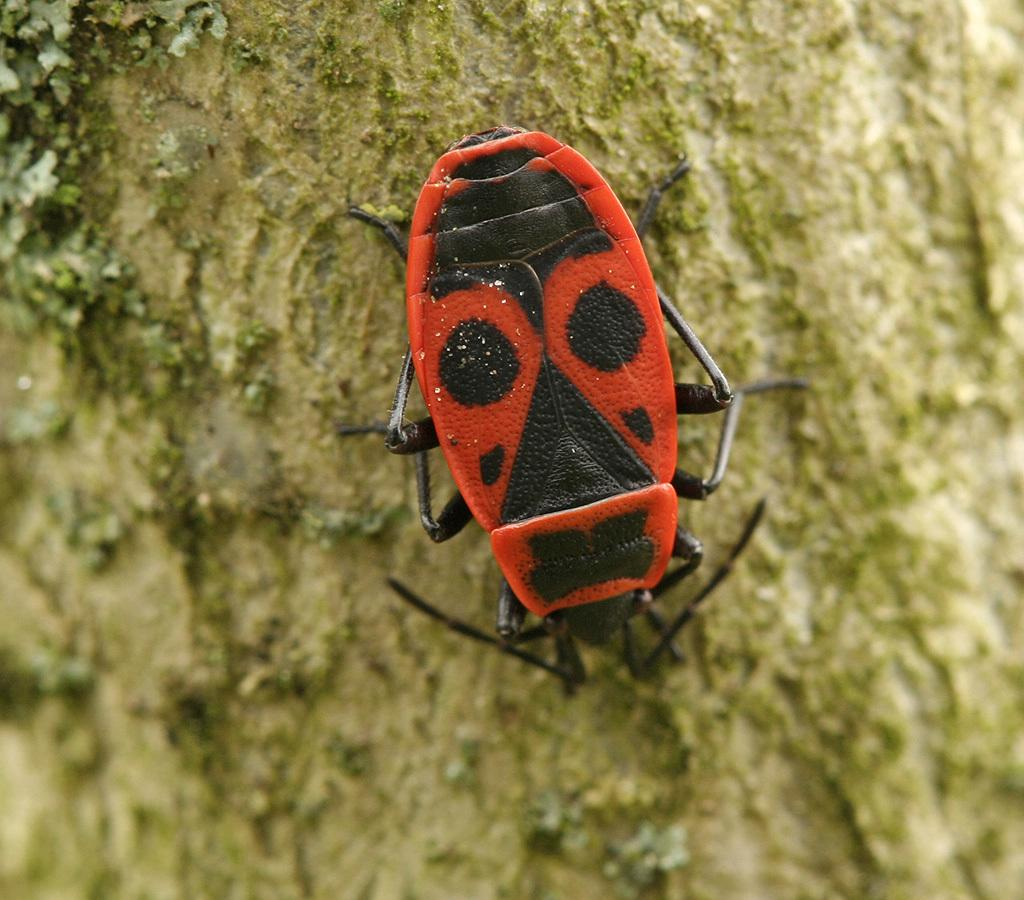What is present on the tree trunk in the image? There is an insect on the trunk of a tree in the image. Can you describe the location of the insect on the tree trunk? The insect is on the trunk of the tree. What type of drum is being played by the insect in the image? There is no drum present in the image, and the insect is not playing any instrument. 